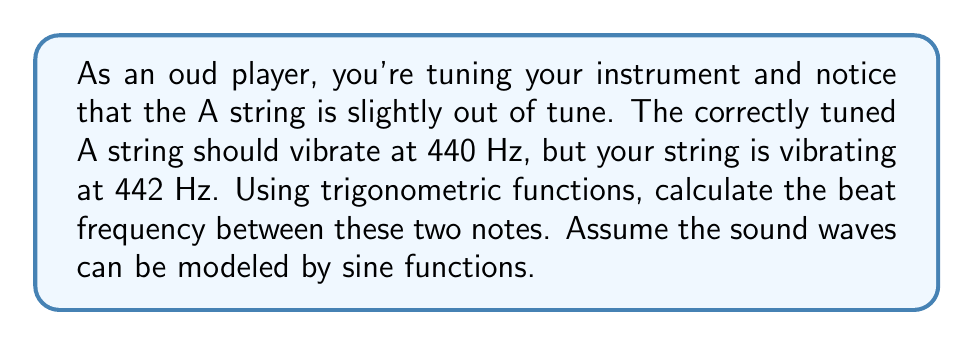What is the answer to this math problem? To solve this problem, we'll follow these steps:

1) First, let's recall that the general form of a sine wave is:
   $$y(t) = A \sin(2\pi ft)$$
   where $A$ is the amplitude, $f$ is the frequency, and $t$ is time.

2) We have two waves:
   Wave 1 (correct tune): $$y_1(t) = A \sin(2\pi \cdot 440t)$$
   Wave 2 (your string): $$y_2(t) = A \sin(2\pi \cdot 442t)$$

3) When these waves interfere, they add together:
   $$y(t) = y_1(t) + y_2(t) = A[\sin(2\pi \cdot 440t) + \sin(2\pi \cdot 442t)]$$

4) We can simplify this using the trigonometric identity:
   $$\sin A + \sin B = 2 \sin(\frac{A+B}{2}) \cos(\frac{A-B}{2})$$

5) Applying this to our equation:
   $$y(t) = 2A \sin(2\pi \cdot 441t) \cos(2\pi \cdot 1t)$$

6) This result shows a wave with:
   - A carrier frequency of 441 Hz (average of 440 and 442)
   - Modulated by a cosine wave with frequency 1 Hz

7) The modulation causes the amplitude to vary at a frequency of 1 Hz. This is the beat frequency.

Therefore, the beat frequency is 1 Hz.
Answer: 1 Hz 